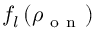Convert formula to latex. <formula><loc_0><loc_0><loc_500><loc_500>f _ { l } \left ( \rho _ { o n } \right )</formula> 